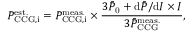<formula> <loc_0><loc_0><loc_500><loc_500>P _ { C C G , i } ^ { e s t . } = P _ { C C G , i } ^ { m e a s . } \times \frac { 3 \bar { P } _ { 0 } + d \bar { P } / d I \times I } { 3 \bar { P } _ { C C G } ^ { m e a s . } } ,</formula> 